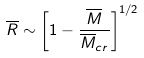<formula> <loc_0><loc_0><loc_500><loc_500>\overline { R } \sim \left [ 1 - \frac { \overline { M } } { \overline { M } _ { c r } } \right ] ^ { 1 / 2 }</formula> 